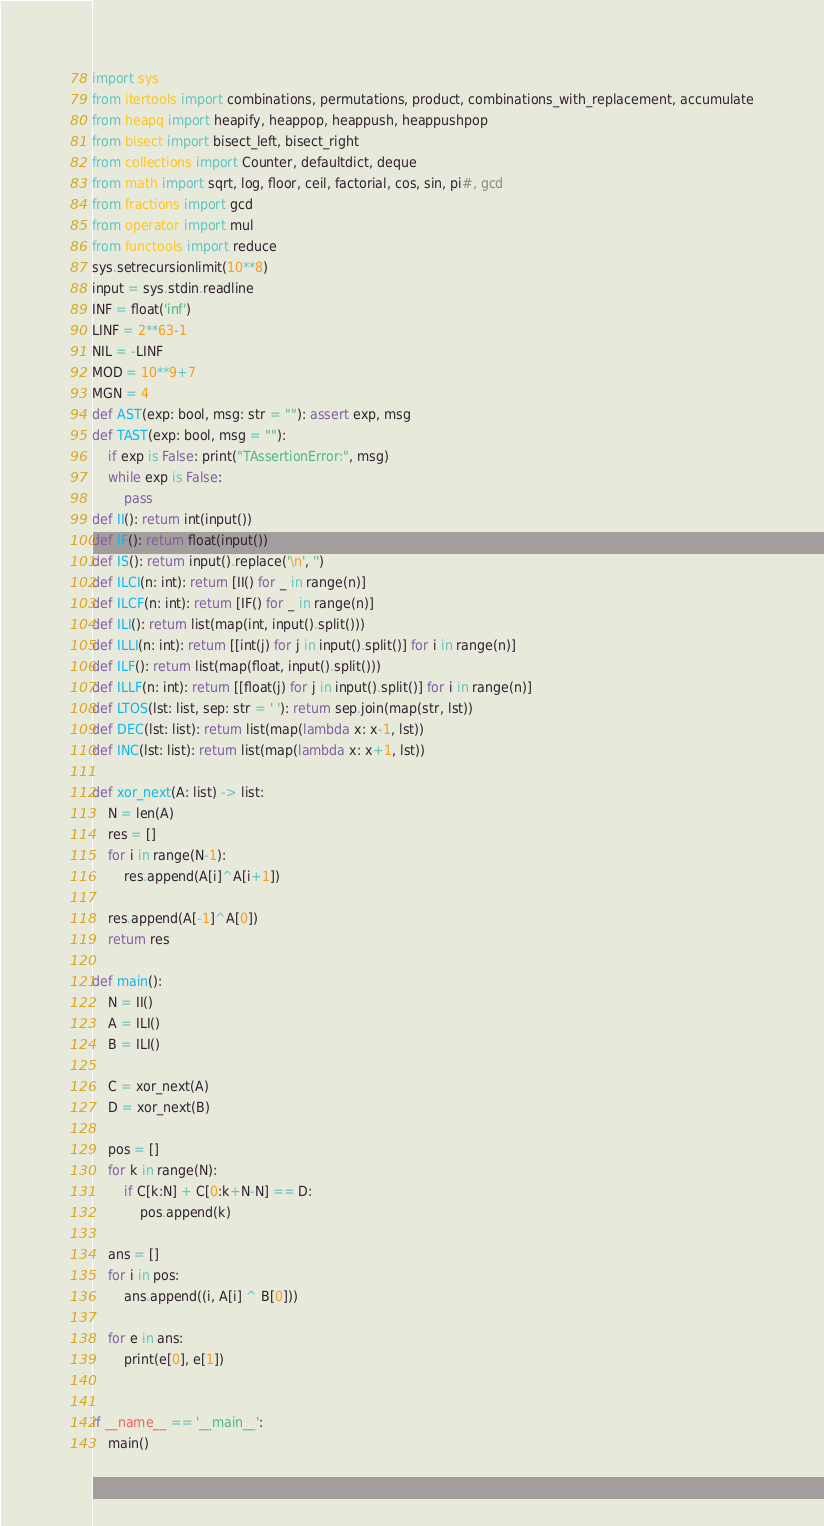Convert code to text. <code><loc_0><loc_0><loc_500><loc_500><_Python_>import sys
from itertools import combinations, permutations, product, combinations_with_replacement, accumulate
from heapq import heapify, heappop, heappush, heappushpop
from bisect import bisect_left, bisect_right
from collections import Counter, defaultdict, deque
from math import sqrt, log, floor, ceil, factorial, cos, sin, pi#, gcd
from fractions import gcd
from operator import mul
from functools import reduce
sys.setrecursionlimit(10**8)
input = sys.stdin.readline
INF = float('inf')
LINF = 2**63-1
NIL = -LINF
MOD = 10**9+7
MGN = 4
def AST(exp: bool, msg: str = ""): assert exp, msg
def TAST(exp: bool, msg = ""):
    if exp is False: print("TAssertionError:", msg)
    while exp is False:
        pass
def II(): return int(input())
def IF(): return float(input())
def IS(): return input().replace('\n', '')
def ILCI(n: int): return [II() for _ in range(n)]
def ILCF(n: int): return [IF() for _ in range(n)]
def ILI(): return list(map(int, input().split()))
def ILLI(n: int): return [[int(j) for j in input().split()] for i in range(n)]
def ILF(): return list(map(float, input().split()))
def ILLF(n: int): return [[float(j) for j in input().split()] for i in range(n)]
def LTOS(lst: list, sep: str = ' '): return sep.join(map(str, lst))
def DEC(lst: list): return list(map(lambda x: x-1, lst))
def INC(lst: list): return list(map(lambda x: x+1, lst))

def xor_next(A: list) -> list:    
    N = len(A)
    res = []
    for i in range(N-1):
        res.append(A[i]^A[i+1])
    
    res.append(A[-1]^A[0])
    return res

def main():
    N = II()
    A = ILI()
    B = ILI()

    C = xor_next(A)
    D = xor_next(B)
    
    pos = []
    for k in range(N):
        if C[k:N] + C[0:k+N-N] == D:
            pos.append(k)

    ans = []
    for i in pos:
        ans.append((i, A[i] ^ B[0]))

    for e in ans:
        print(e[0], e[1])


if __name__ == '__main__':
    main()
</code> 